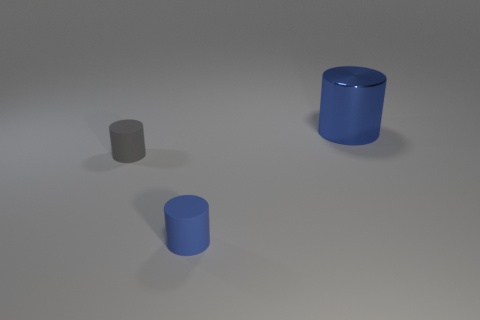Is there any other thing that has the same material as the large blue thing?
Keep it short and to the point. No. There is a thing on the right side of the blue rubber object; is it the same color as the tiny matte cylinder in front of the gray thing?
Make the answer very short. Yes. What is the shape of the small matte thing that is the same color as the shiny cylinder?
Provide a short and direct response. Cylinder. How big is the thing that is both behind the tiny blue matte object and to the right of the gray matte cylinder?
Make the answer very short. Large. How many tiny blue rubber cylinders are there?
Your answer should be very brief. 1. What number of cylinders are rubber objects or large blue objects?
Provide a succinct answer. 3. There is a blue cylinder to the left of the thing that is behind the tiny gray object; how many big objects are in front of it?
Your response must be concise. 0. What color is the cylinder that is the same size as the blue matte object?
Your answer should be compact. Gray. How many other objects are there of the same color as the large metal thing?
Keep it short and to the point. 1. Are there more big metallic things behind the tiny blue thing than cyan shiny objects?
Keep it short and to the point. Yes. 